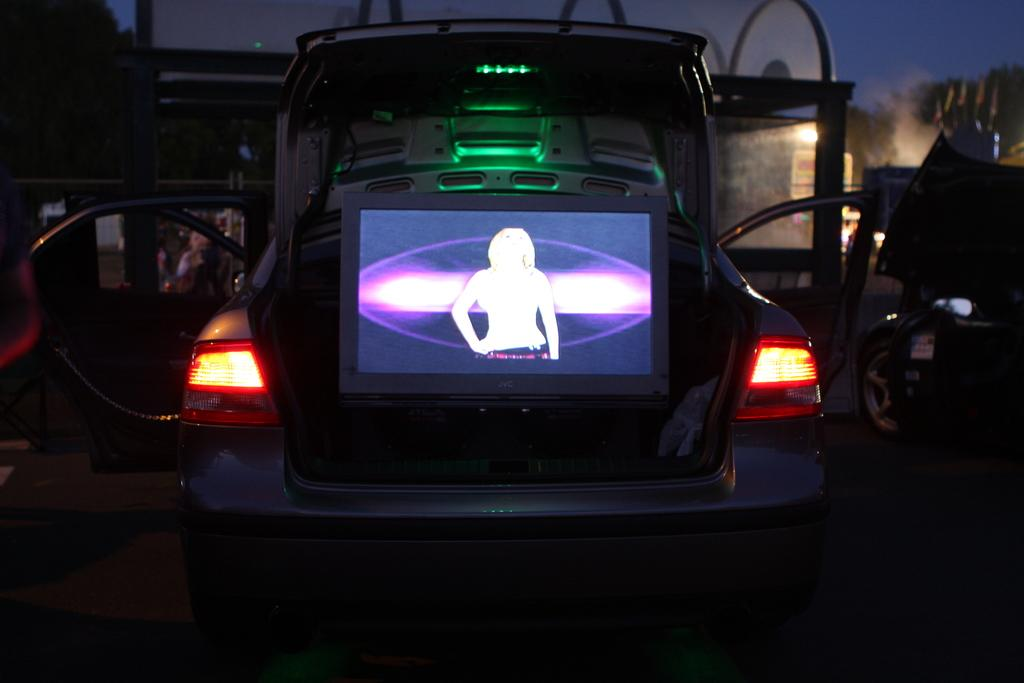What type of vehicles can be seen in the image? There are cars in the image. What electronic device is inside one of the cars? There is a laptop inside one of the cars. What structures can be seen in the background of the image? There is a shed, a board, and a light in the background of the image. What type of vegetation is visible in the background of the image? There are trees in the background of the image. What part of the natural environment is visible in the image? The sky is visible in the background of the image. What time of day is it in the image, and can you hear the people laughing? The time of day is not mentioned in the image, and there is no indication of people laughing. 